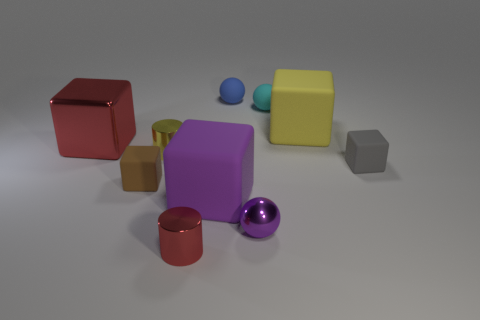Subtract 1 cubes. How many cubes are left? 4 Subtract all purple cubes. How many cubes are left? 4 Subtract all brown rubber cubes. How many cubes are left? 4 Subtract all red blocks. Subtract all red cylinders. How many blocks are left? 4 Subtract all spheres. How many objects are left? 7 Subtract 0 purple cylinders. How many objects are left? 10 Subtract all brown objects. Subtract all matte blocks. How many objects are left? 5 Add 6 large purple cubes. How many large purple cubes are left? 7 Add 9 large red metallic balls. How many large red metallic balls exist? 9 